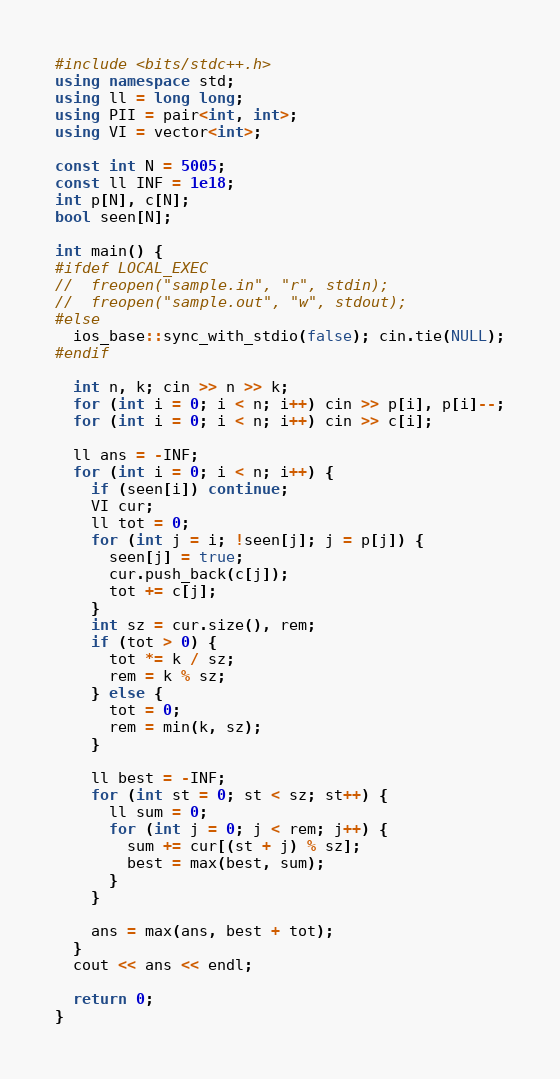<code> <loc_0><loc_0><loc_500><loc_500><_C++_>#include <bits/stdc++.h>
using namespace std;
using ll = long long;
using PII = pair<int, int>;
using VI = vector<int>;

const int N = 5005;
const ll INF = 1e18;
int p[N], c[N];
bool seen[N];

int main() {
#ifdef LOCAL_EXEC
//	freopen("sample.in", "r", stdin);
//	freopen("sample.out", "w", stdout);
#else
  ios_base::sync_with_stdio(false); cin.tie(NULL);
#endif

  int n, k; cin >> n >> k;
  for (int i = 0; i < n; i++) cin >> p[i], p[i]--;
  for (int i = 0; i < n; i++) cin >> c[i];

  ll ans = -INF;
  for (int i = 0; i < n; i++) {
    if (seen[i]) continue;
    VI cur;
    ll tot = 0;
    for (int j = i; !seen[j]; j = p[j]) {
      seen[j] = true;
      cur.push_back(c[j]);
      tot += c[j];
    }
    int sz = cur.size(), rem;
    if (tot > 0) {
      tot *= k / sz;
      rem = k % sz;
    } else {
      tot = 0;
      rem = min(k, sz);
    }

    ll best = -INF;
    for (int st = 0; st < sz; st++) {
      ll sum = 0;
      for (int j = 0; j < rem; j++) {
        sum += cur[(st + j) % sz];
        best = max(best, sum);
      }
    }

    ans = max(ans, best + tot);
  }
  cout << ans << endl;

  return 0;
}
</code> 